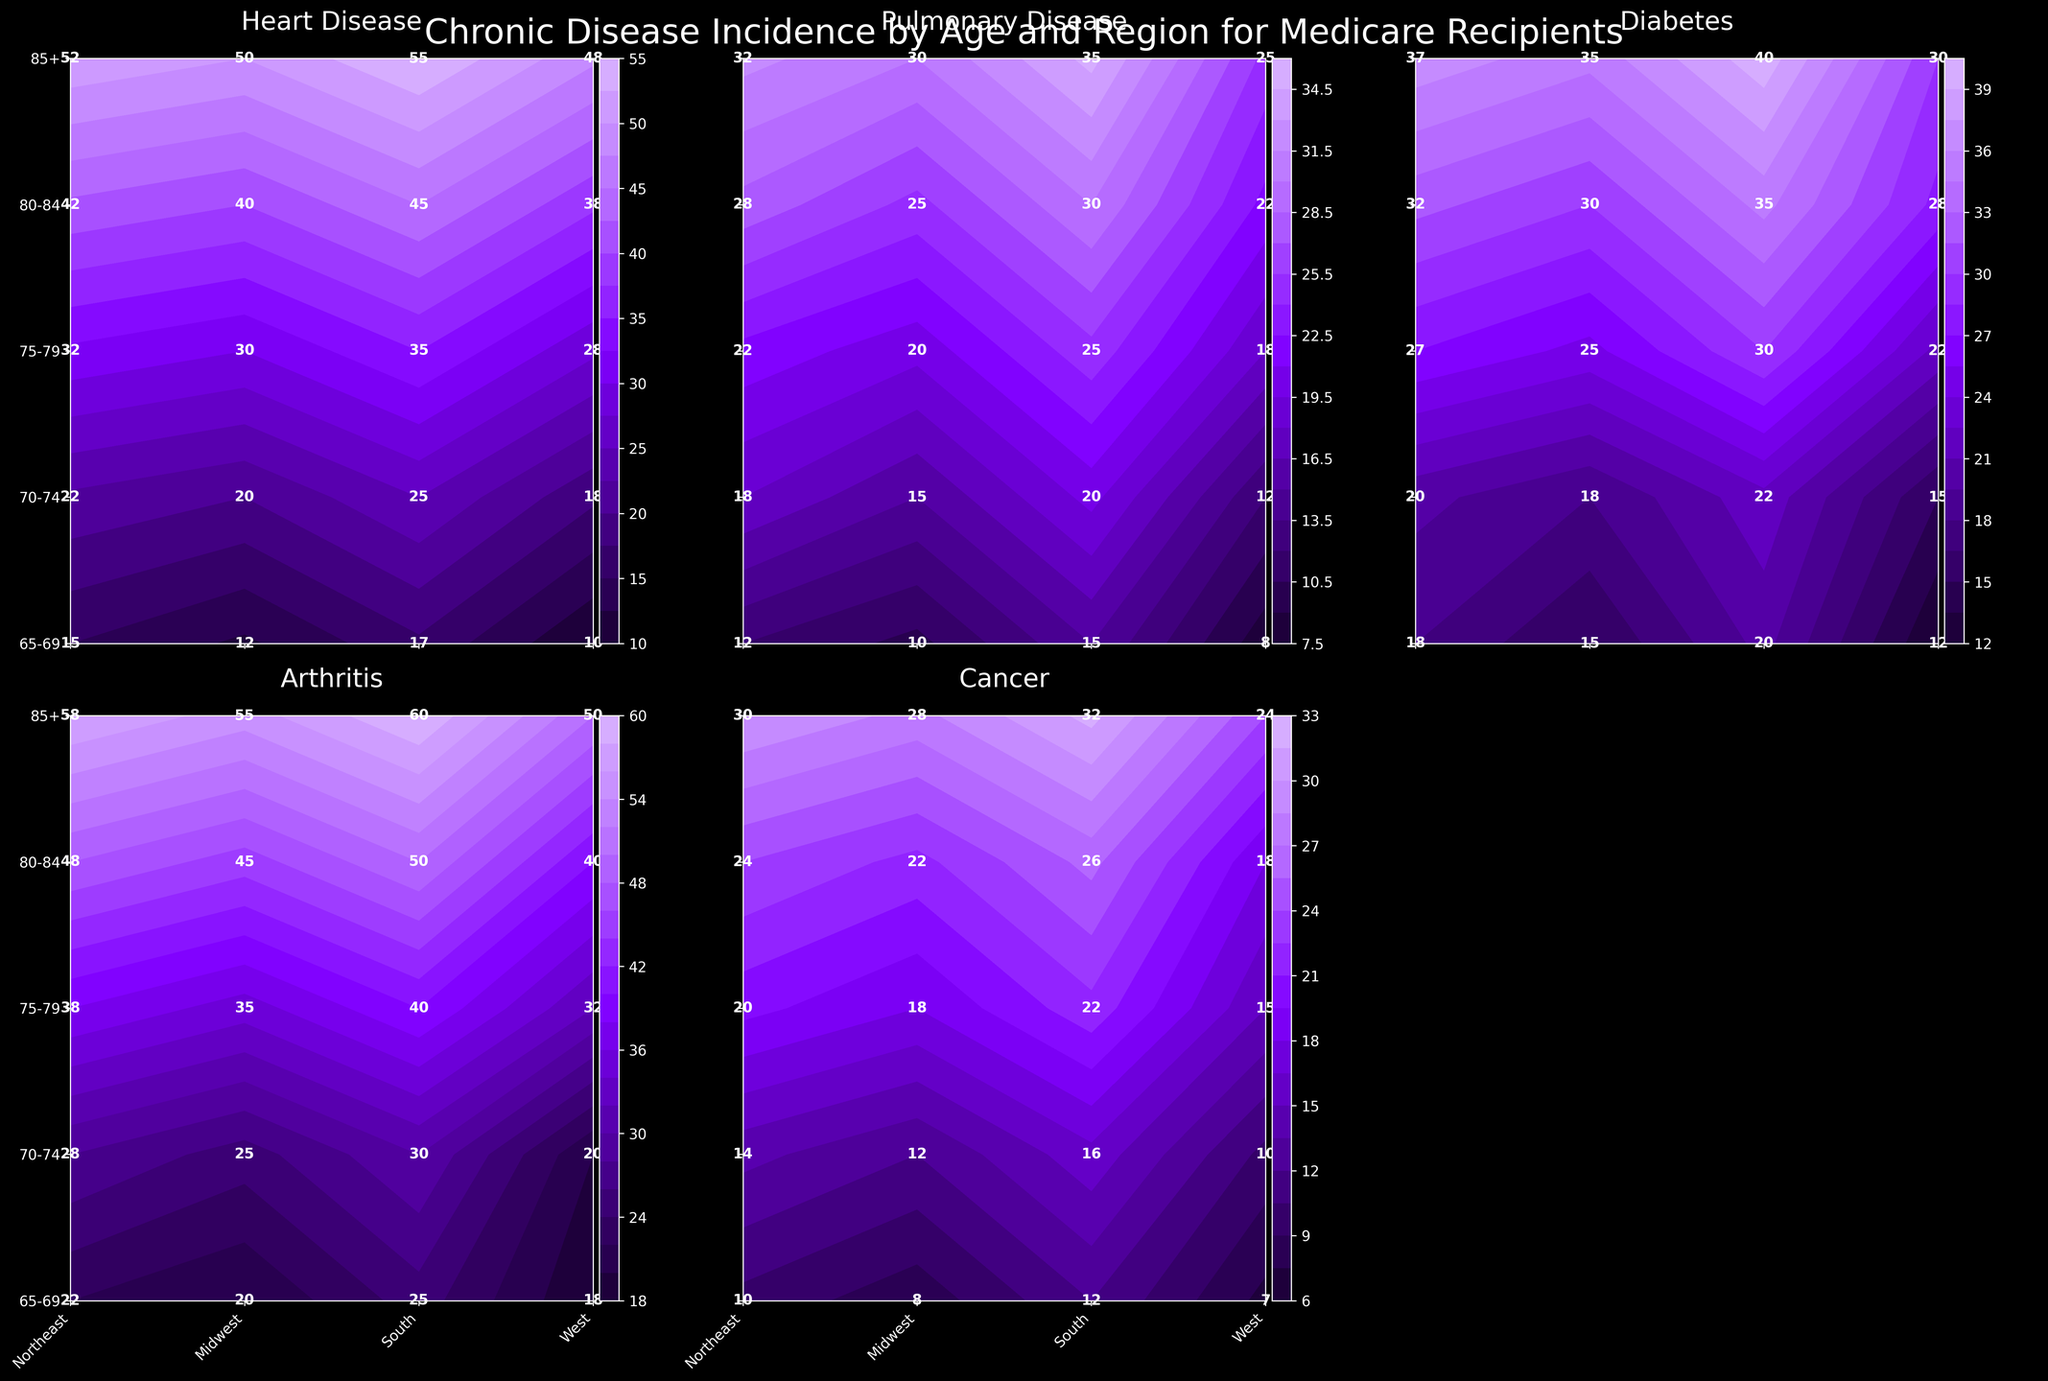Which region shows the highest incidence of heart disease in the 85+ age group? In the "Heart Disease" plot, identify the region with the highest value in the 85+ age group row. The value for South is the highest at 55.
Answer: South What's the average incidence of arthritis for the age group 70-74 across all regions? In the "Arthritis" plot, locate the 70-74 age group row and find the values for all regions: Northeast (25), Midwest (28), South (30), and West (20). The average is (25+28+30+20)/4 = 25.75.
Answer: 25.75 Which disease has the lowest incidence in the West region for the 80-84 age group? Check all the diseases for the West region in the 80-84 age group: Heart Disease (38), Pulmonary Disease (22), Diabetes (28), Arthritis (40), Cancer (18). The lowest value is for Cancer at 18.
Answer: Cancer What's the difference in the incidence of diabetes between the Midwest and South regions for the 65-69 age group? In the "Diabetes" plot, find the values for 65-69 age group in Midwest (18) and South (20). The difference is 20 - 18 = 2.
Answer: 2 How does the incidence of pulmonary disease in the Northeast compare between the age groups 65-69 and 85+? In the "Pulmonary Disease" plot, check the values for Northeast: 65-69 (10) and 85+ (30). 30 is greater than 10.
Answer: 30 > 10 Which age group in the Midwest shows the highest incidence of cancer? Check the "Cancer" plot for the Midwest across all the age groups: 65-69 (10), 70-74 (14), 75-79 (20), 80-84 (24), 85+ (30). The highest value is 30 for 85+.
Answer: 85+ Compare the trend of heart disease incidence from 65-69 to 85+ age groups for the West region. How does it change? In the "Heart Disease" plot, examine the West region for 65-69 (10), 70-74 (18), 75-79 (28), 80-84 (38), 85+ (48). The incidence increases progressively as age increases.
Answer: Increases 